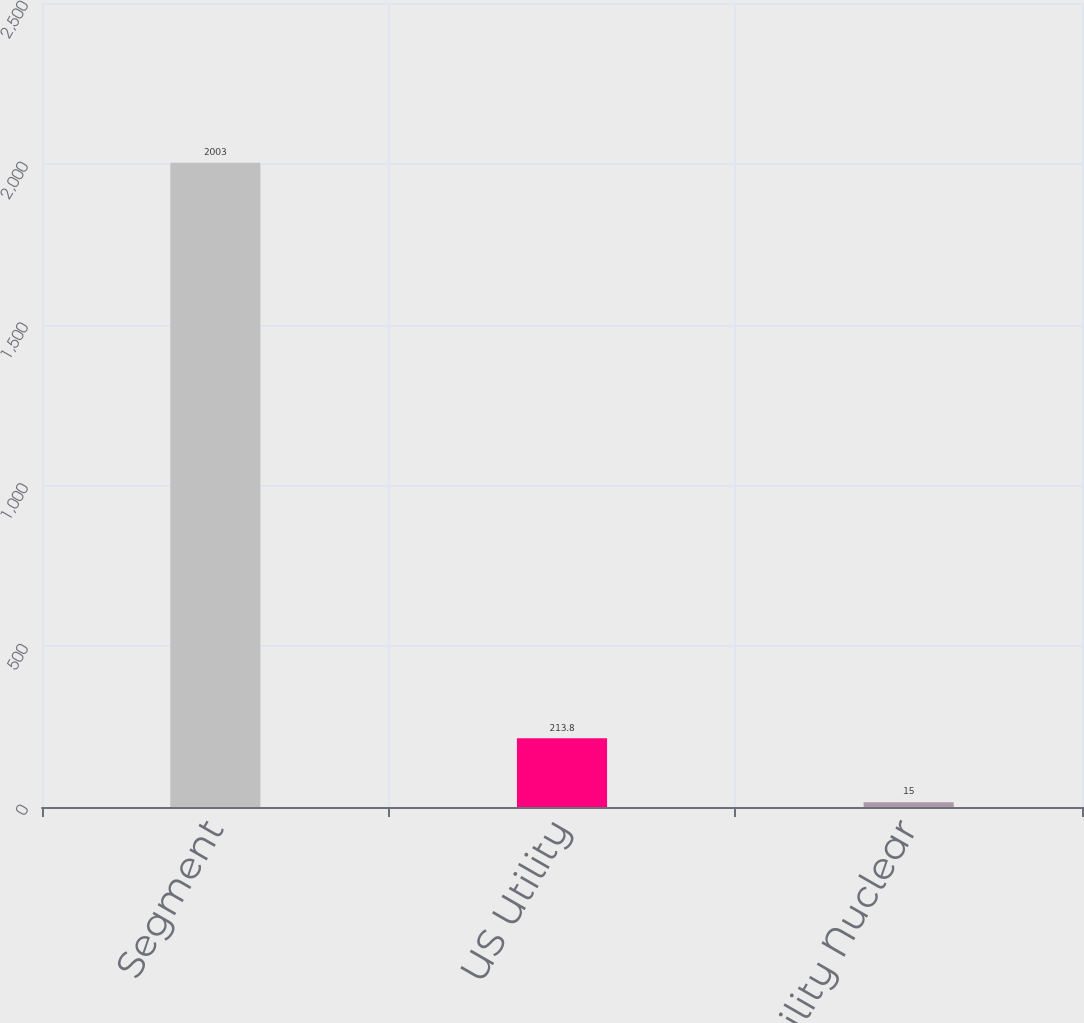Convert chart. <chart><loc_0><loc_0><loc_500><loc_500><bar_chart><fcel>Segment<fcel>US Utility<fcel>Non-Utility Nuclear<nl><fcel>2003<fcel>213.8<fcel>15<nl></chart> 